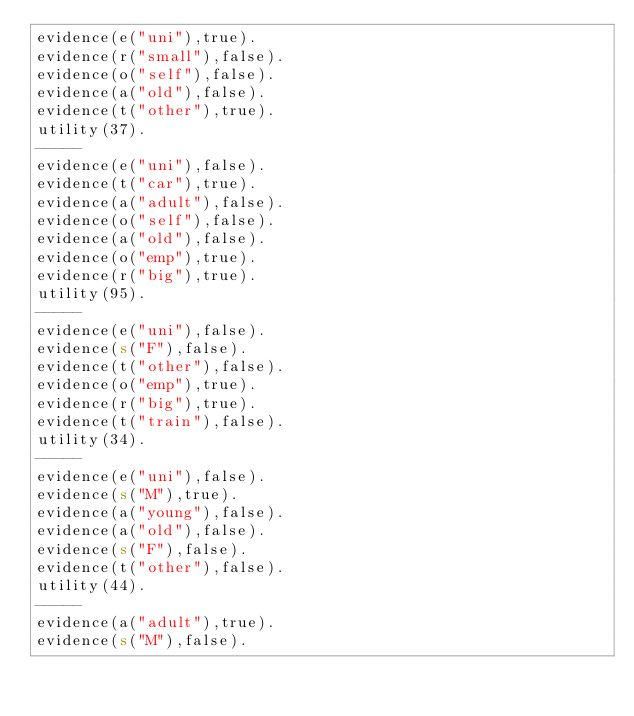Convert code to text. <code><loc_0><loc_0><loc_500><loc_500><_Perl_>evidence(e("uni"),true).
evidence(r("small"),false).
evidence(o("self"),false).
evidence(a("old"),false).
evidence(t("other"),true).
utility(37).
-----
evidence(e("uni"),false).
evidence(t("car"),true).
evidence(a("adult"),false).
evidence(o("self"),false).
evidence(a("old"),false).
evidence(o("emp"),true).
evidence(r("big"),true).
utility(95).
-----
evidence(e("uni"),false).
evidence(s("F"),false).
evidence(t("other"),false).
evidence(o("emp"),true).
evidence(r("big"),true).
evidence(t("train"),false).
utility(34).
-----
evidence(e("uni"),false).
evidence(s("M"),true).
evidence(a("young"),false).
evidence(a("old"),false).
evidence(s("F"),false).
evidence(t("other"),false).
utility(44).
-----
evidence(a("adult"),true).
evidence(s("M"),false).</code> 